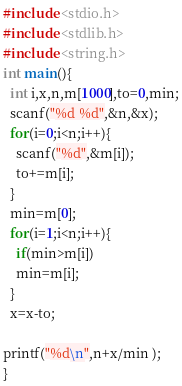<code> <loc_0><loc_0><loc_500><loc_500><_C_>#include <stdio.h>
#include <stdlib.h>
#include <string.h>
int main(){
  int i,x,n,m[1000],to=0,min;
  scanf("%d %d",&n,&x);
  for(i=0;i<n;i++){
    scanf("%d",&m[i]);
    to+=m[i];
  }
  min=m[0];
  for(i=1;i<n;i++){
    if(min>m[i])
    min=m[i];
  }
  x=x-to;

printf("%d\n",n+x/min );
}
</code> 